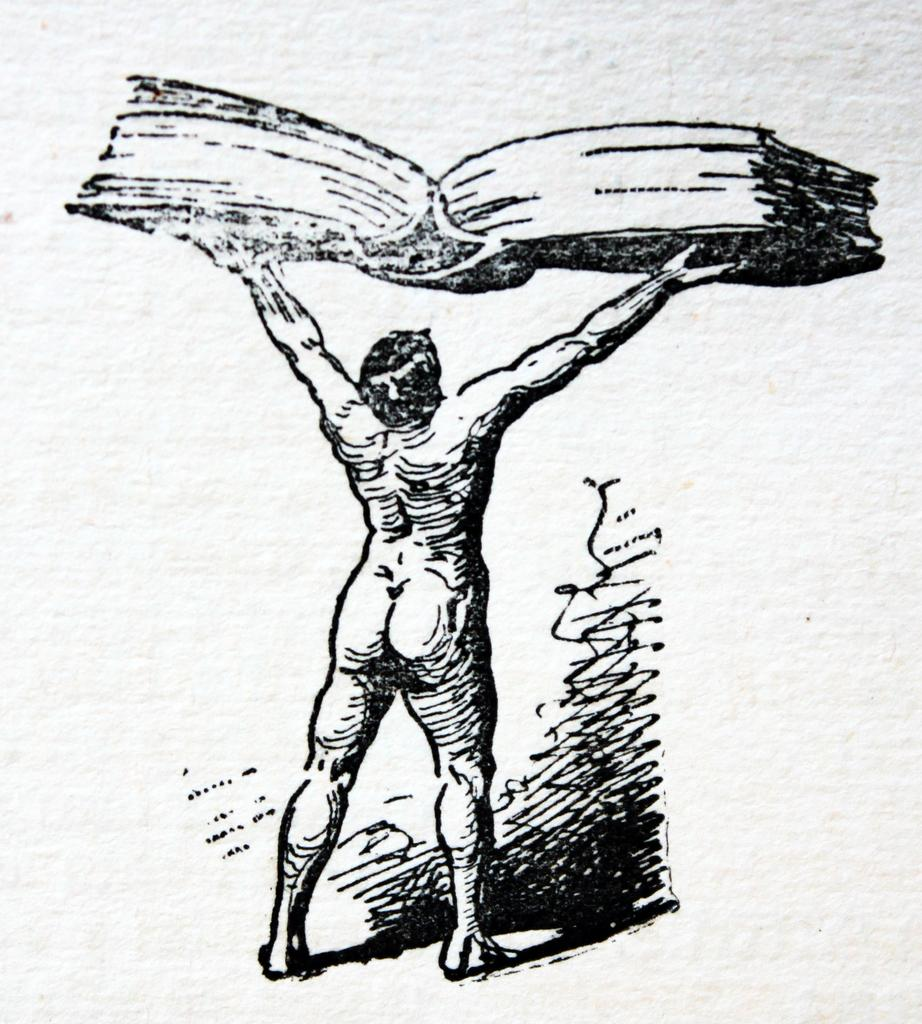What is depicted on the paper in the image? There is a sketch on paper in the image. What is the main subject in the center of the image? There is a man standing in the center of the image. What is the man holding in the image? The man is holding a book in the image. What year is the man discussing with the others in the image? There is no indication of a discussion or others present in the image; it only shows a man holding a book and a sketch on paper. 